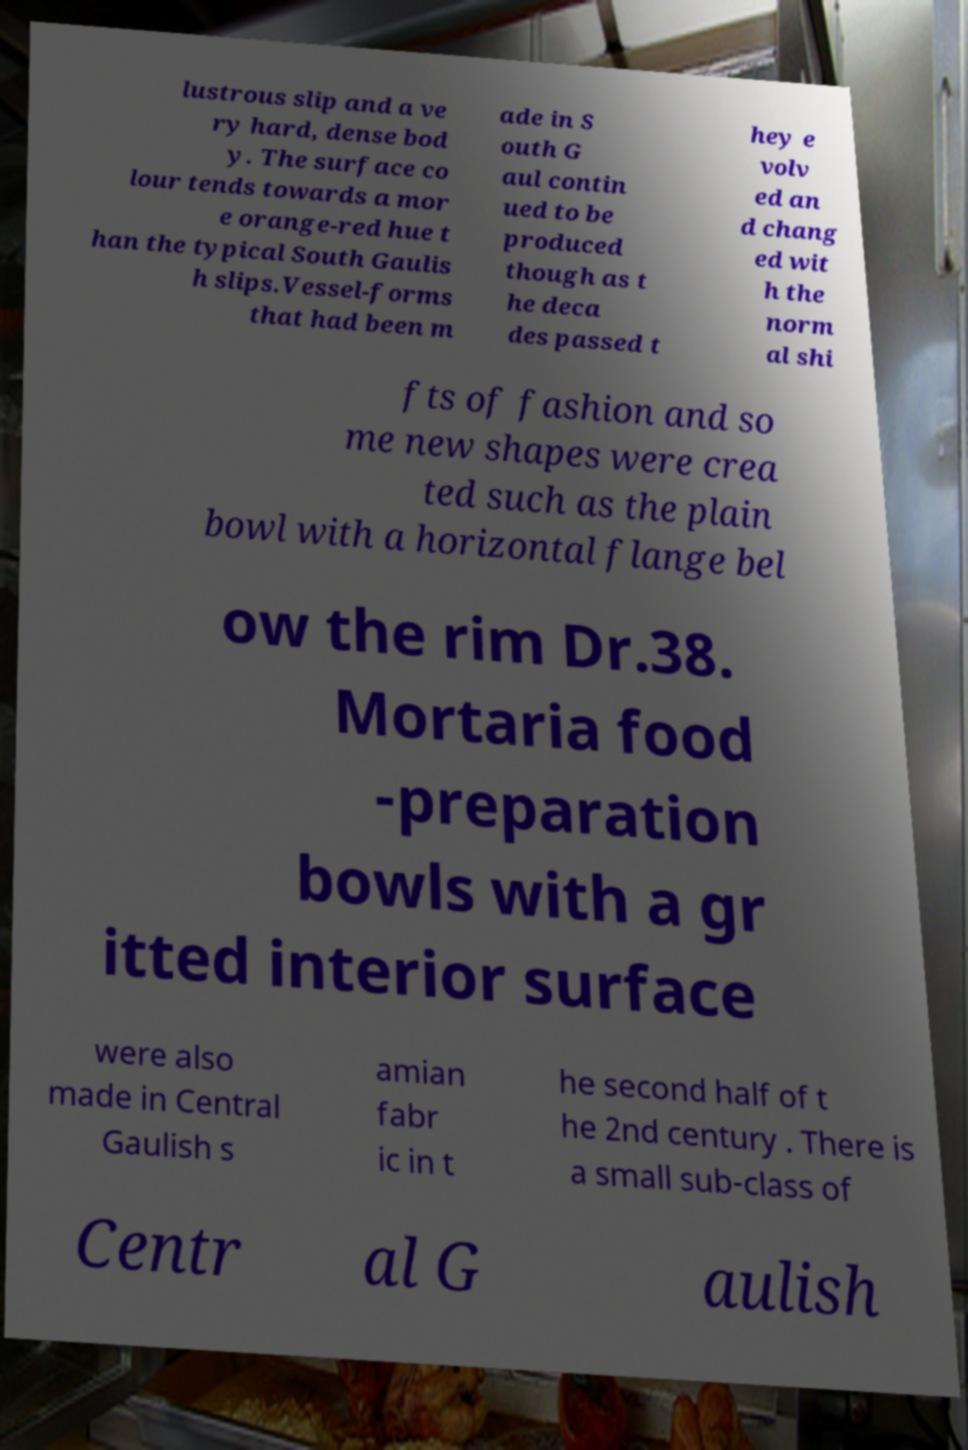For documentation purposes, I need the text within this image transcribed. Could you provide that? lustrous slip and a ve ry hard, dense bod y. The surface co lour tends towards a mor e orange-red hue t han the typical South Gaulis h slips.Vessel-forms that had been m ade in S outh G aul contin ued to be produced though as t he deca des passed t hey e volv ed an d chang ed wit h the norm al shi fts of fashion and so me new shapes were crea ted such as the plain bowl with a horizontal flange bel ow the rim Dr.38. Mortaria food -preparation bowls with a gr itted interior surface were also made in Central Gaulish s amian fabr ic in t he second half of t he 2nd century . There is a small sub-class of Centr al G aulish 